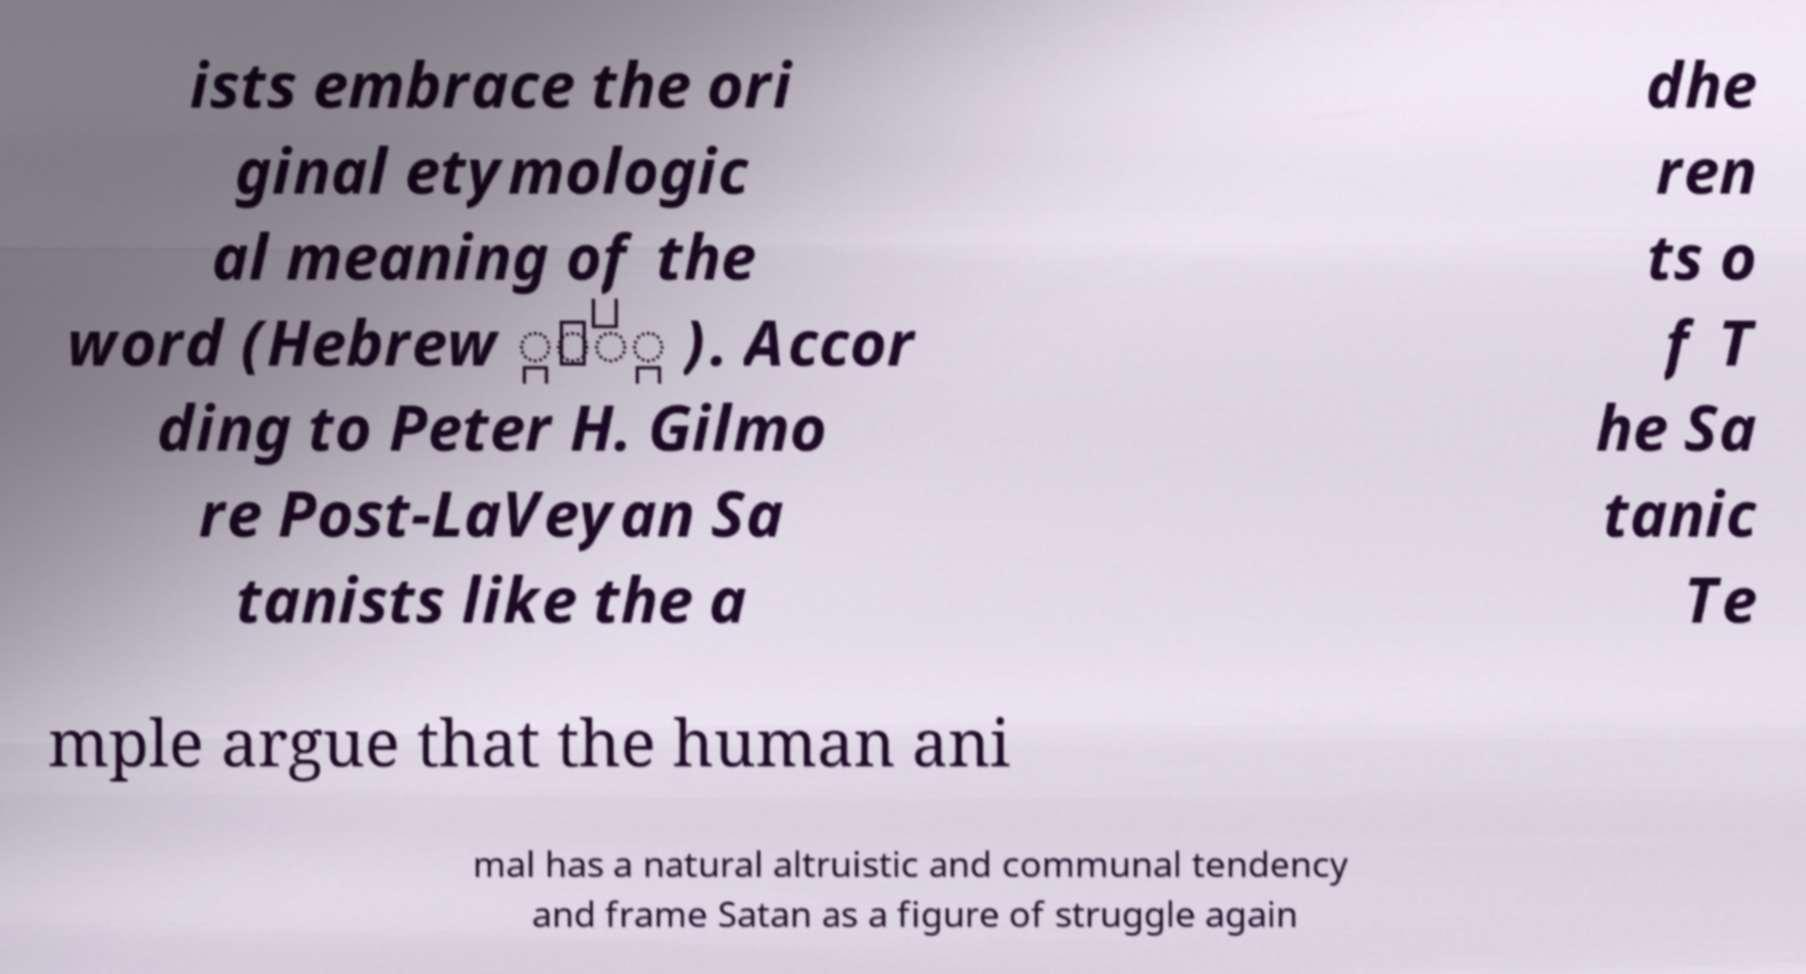Can you read and provide the text displayed in the image?This photo seems to have some interesting text. Can you extract and type it out for me? ists embrace the ori ginal etymologic al meaning of the word (Hebrew ָָּׂ ). Accor ding to Peter H. Gilmo re Post-LaVeyan Sa tanists like the a dhe ren ts o f T he Sa tanic Te mple argue that the human ani mal has a natural altruistic and communal tendency and frame Satan as a figure of struggle again 